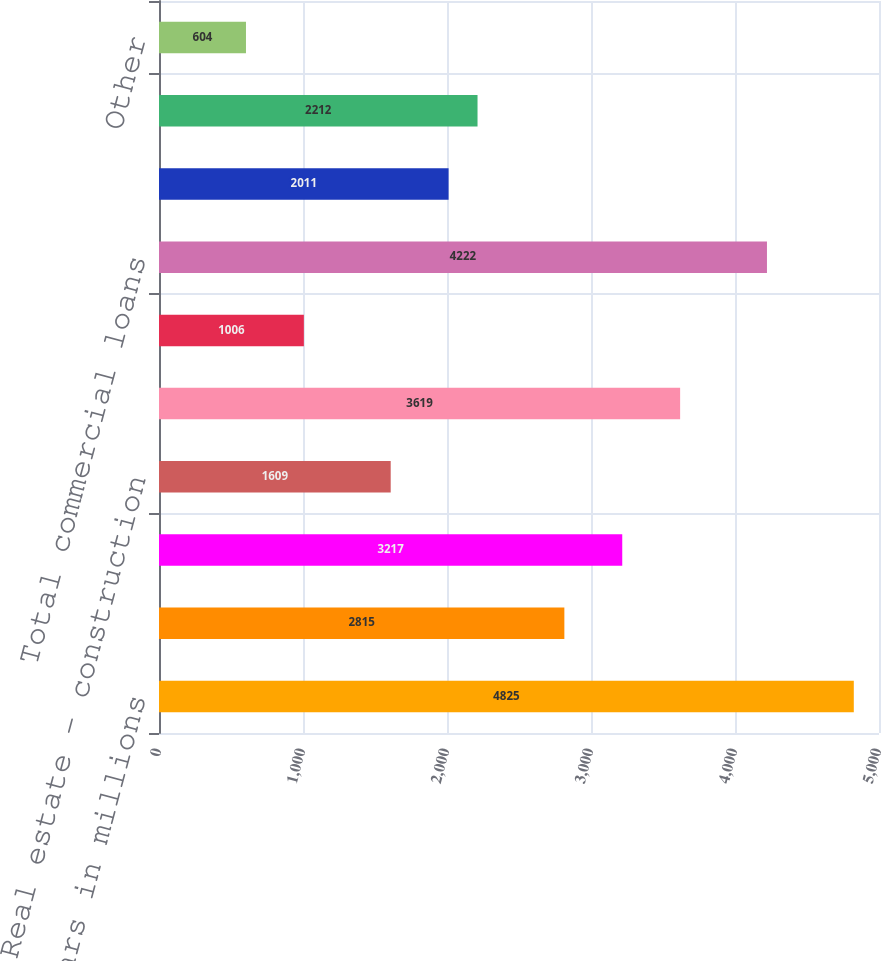Convert chart. <chart><loc_0><loc_0><loc_500><loc_500><bar_chart><fcel>dollars in millions<fcel>Commercial financial and<fcel>Real estate - commercial<fcel>Real estate - construction<fcel>Total commercial real estate<fcel>Commercial lease financing<fcel>Total commercial loans<fcel>Real estate - residential<fcel>Key Community Bank<fcel>Other<nl><fcel>4825<fcel>2815<fcel>3217<fcel>1609<fcel>3619<fcel>1006<fcel>4222<fcel>2011<fcel>2212<fcel>604<nl></chart> 